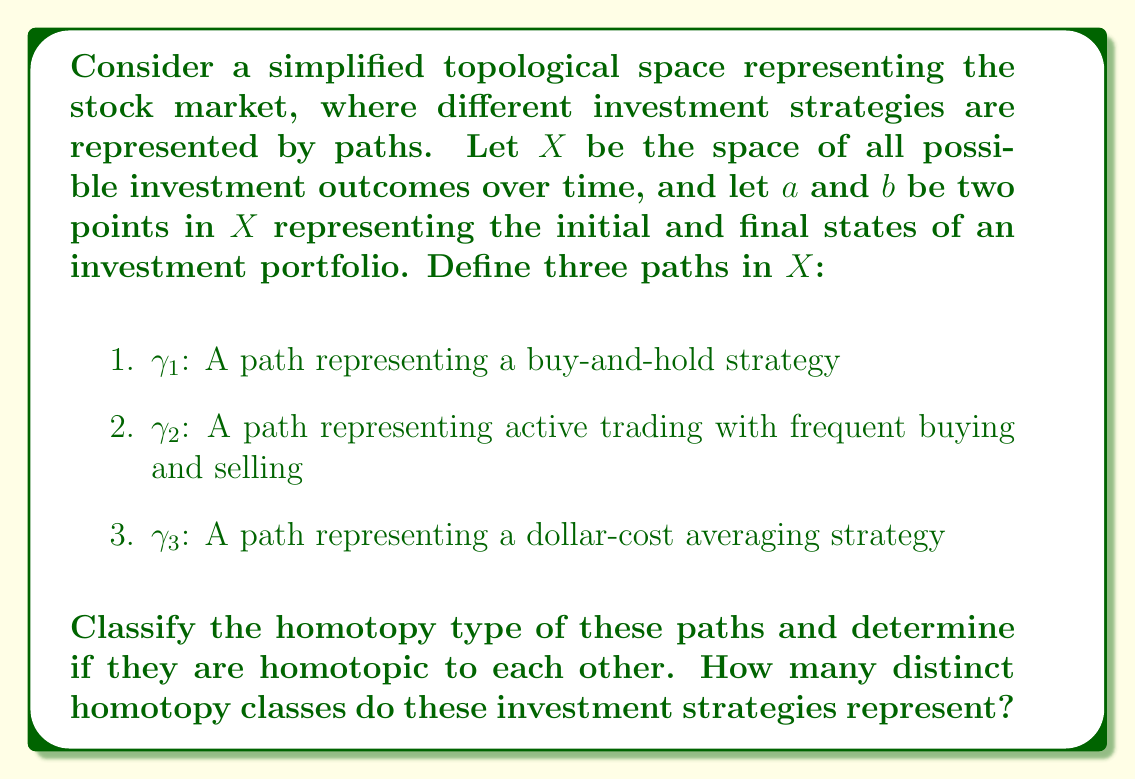Provide a solution to this math problem. To approach this problem, we need to consider the nature of the paths in the context of a topological space representing the stock market:

1. First, let's consider the properties of the space $X$:
   - $X$ is likely to be path-connected, as it's possible to transition between any two portfolio states over time.
   - $X$ may have "holes" or obstacles representing market crashes or periods of high volatility.

2. Now, let's analyze each path:

   a) $\gamma_1$ (buy-and-hold strategy):
      - This path is likely to be relatively smooth and direct from $a$ to $b$.
      - It avoids frequent changes in direction.

   b) $\gamma_2$ (active trading):
      - This path may have many oscillations and changes in direction.
      - However, it still connects $a$ to $b$ within $X$.

   c) $\gamma_3$ (dollar-cost averaging):
      - This path is likely to be smoother than $\gamma_2$ but with more regular fluctuations than $\gamma_1$.

3. Homotopy analysis:
   - Two paths are homotopic if one can be continuously deformed into the other without leaving the space $X$.
   - In this case, all three paths connect the same starting point $a$ to the same endpoint $b$.
   - Assuming there are no "holes" or obstacles in $X$ that would prevent continuous deformation between these paths, we can conclude that all three paths are homotopic to each other.

4. Homotopy classes:
   - Since all paths are homotopic to each other, they belong to the same homotopy class.
   - The number of distinct homotopy classes is therefore 1.

5. Interpretation in the context of investing:
   - From a topological perspective, this result suggests that despite the different approaches, all these investment strategies can be viewed as equivalent in terms of their fundamental ability to transition from the initial state to the final state.
   - However, it's important to note that while topologically equivalent, these strategies may have very different practical outcomes in terms of returns and risk.
Answer: All three paths ($\gamma_1$, $\gamma_2$, and $\gamma_3$) are homotopic to each other, representing a single homotopy class. 